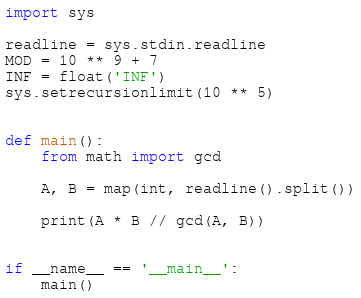<code> <loc_0><loc_0><loc_500><loc_500><_Python_>import sys

readline = sys.stdin.readline
MOD = 10 ** 9 + 7
INF = float('INF')
sys.setrecursionlimit(10 ** 5)


def main():
    from math import gcd

    A, B = map(int, readline().split())

    print(A * B // gcd(A, B))


if __name__ == '__main__':
    main()
</code> 